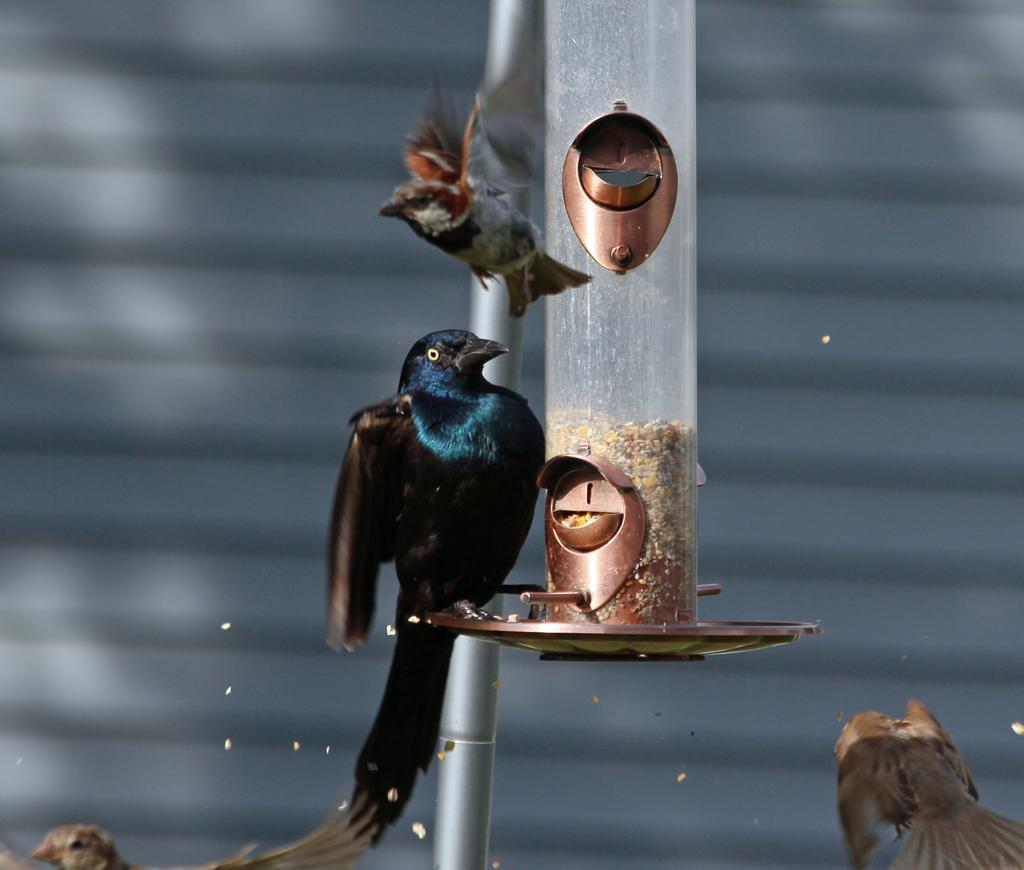What is on the stand of the bird feeder in the image? There is there a bird on the stand of the bird feeder in the image? What else can be seen in the image besides the bird on the feeder? There is a pole and additional birds visible in the image. What type of haircut does the bird on the feeder have in the image? There is no indication of a haircut for the bird in the image, as birds do not have hair. 